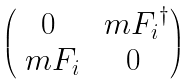Convert formula to latex. <formula><loc_0><loc_0><loc_500><loc_500>\begin{pmatrix} 0 & { \ m F _ { i } } ^ { \dagger } \\ \ m F _ { i } & 0 \\ \end{pmatrix}</formula> 